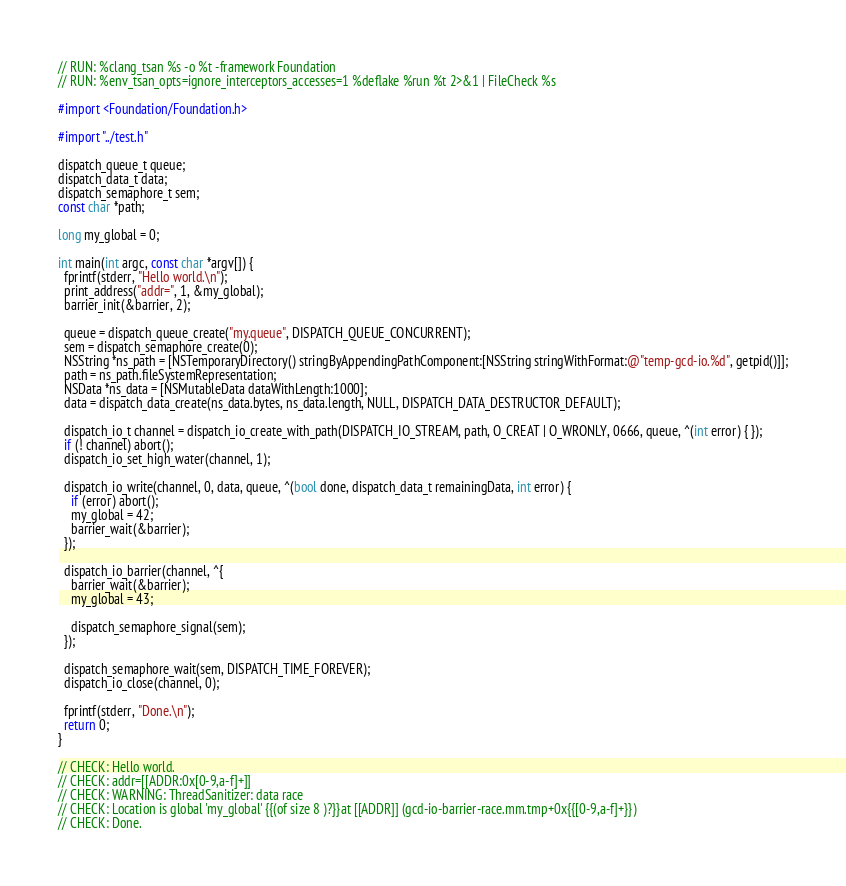<code> <loc_0><loc_0><loc_500><loc_500><_ObjectiveC_>// RUN: %clang_tsan %s -o %t -framework Foundation
// RUN: %env_tsan_opts=ignore_interceptors_accesses=1 %deflake %run %t 2>&1 | FileCheck %s

#import <Foundation/Foundation.h>

#import "../test.h"

dispatch_queue_t queue;
dispatch_data_t data;
dispatch_semaphore_t sem;
const char *path;

long my_global = 0;

int main(int argc, const char *argv[]) {
  fprintf(stderr, "Hello world.\n");
  print_address("addr=", 1, &my_global);
  barrier_init(&barrier, 2);

  queue = dispatch_queue_create("my.queue", DISPATCH_QUEUE_CONCURRENT);
  sem = dispatch_semaphore_create(0);
  NSString *ns_path = [NSTemporaryDirectory() stringByAppendingPathComponent:[NSString stringWithFormat:@"temp-gcd-io.%d", getpid()]];
  path = ns_path.fileSystemRepresentation;
  NSData *ns_data = [NSMutableData dataWithLength:1000];
  data = dispatch_data_create(ns_data.bytes, ns_data.length, NULL, DISPATCH_DATA_DESTRUCTOR_DEFAULT);
  
  dispatch_io_t channel = dispatch_io_create_with_path(DISPATCH_IO_STREAM, path, O_CREAT | O_WRONLY, 0666, queue, ^(int error) { });
  if (! channel) abort();
  dispatch_io_set_high_water(channel, 1);

  dispatch_io_write(channel, 0, data, queue, ^(bool done, dispatch_data_t remainingData, int error) {
    if (error) abort();
    my_global = 42;
    barrier_wait(&barrier);
  });

  dispatch_io_barrier(channel, ^{
    barrier_wait(&barrier);
    my_global = 43;

    dispatch_semaphore_signal(sem);
  });

  dispatch_semaphore_wait(sem, DISPATCH_TIME_FOREVER);
  dispatch_io_close(channel, 0);
  
  fprintf(stderr, "Done.\n");
  return 0;
}

// CHECK: Hello world.
// CHECK: addr=[[ADDR:0x[0-9,a-f]+]]
// CHECK: WARNING: ThreadSanitizer: data race
// CHECK: Location is global 'my_global' {{(of size 8 )?}}at [[ADDR]] (gcd-io-barrier-race.mm.tmp+0x{{[0-9,a-f]+}})
// CHECK: Done.
</code> 